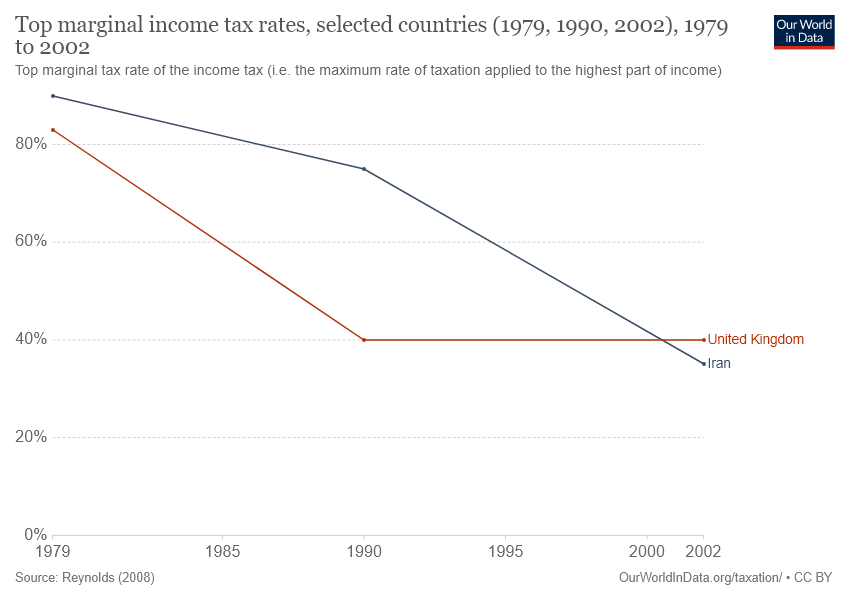Draw attention to some important aspects in this diagram. There are 2 lines present in the graph. The starting percentage value of the orange line is 44, and when it crosses the other line, its percentage value increases. 